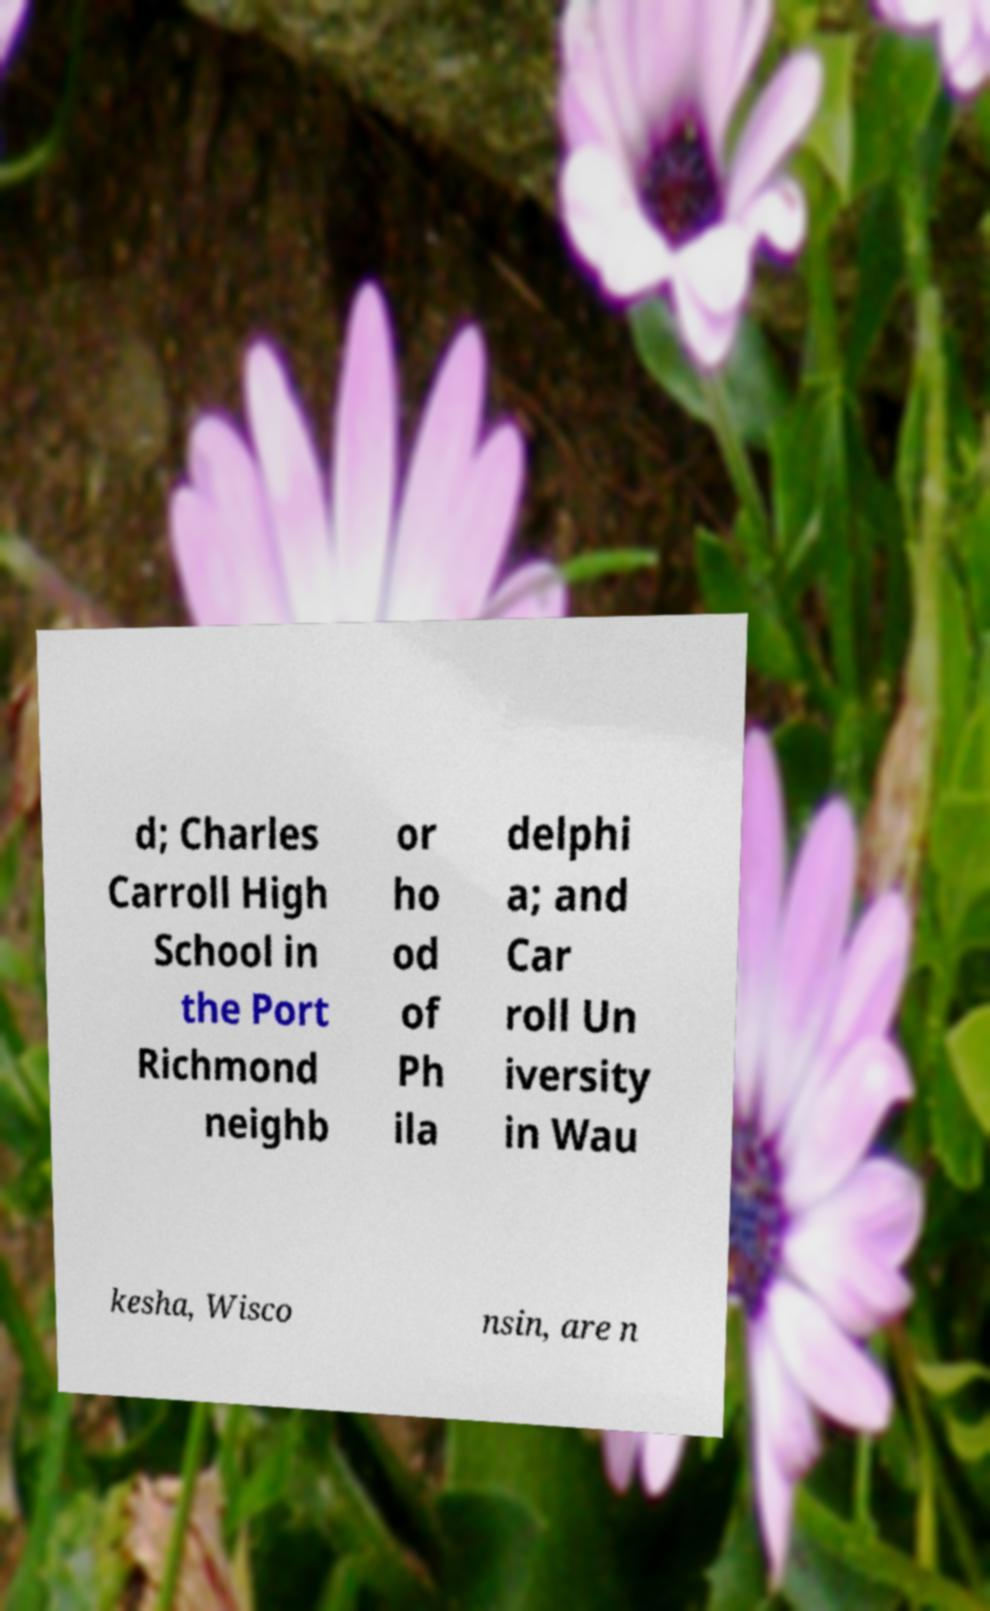Please read and relay the text visible in this image. What does it say? d; Charles Carroll High School in the Port Richmond neighb or ho od of Ph ila delphi a; and Car roll Un iversity in Wau kesha, Wisco nsin, are n 